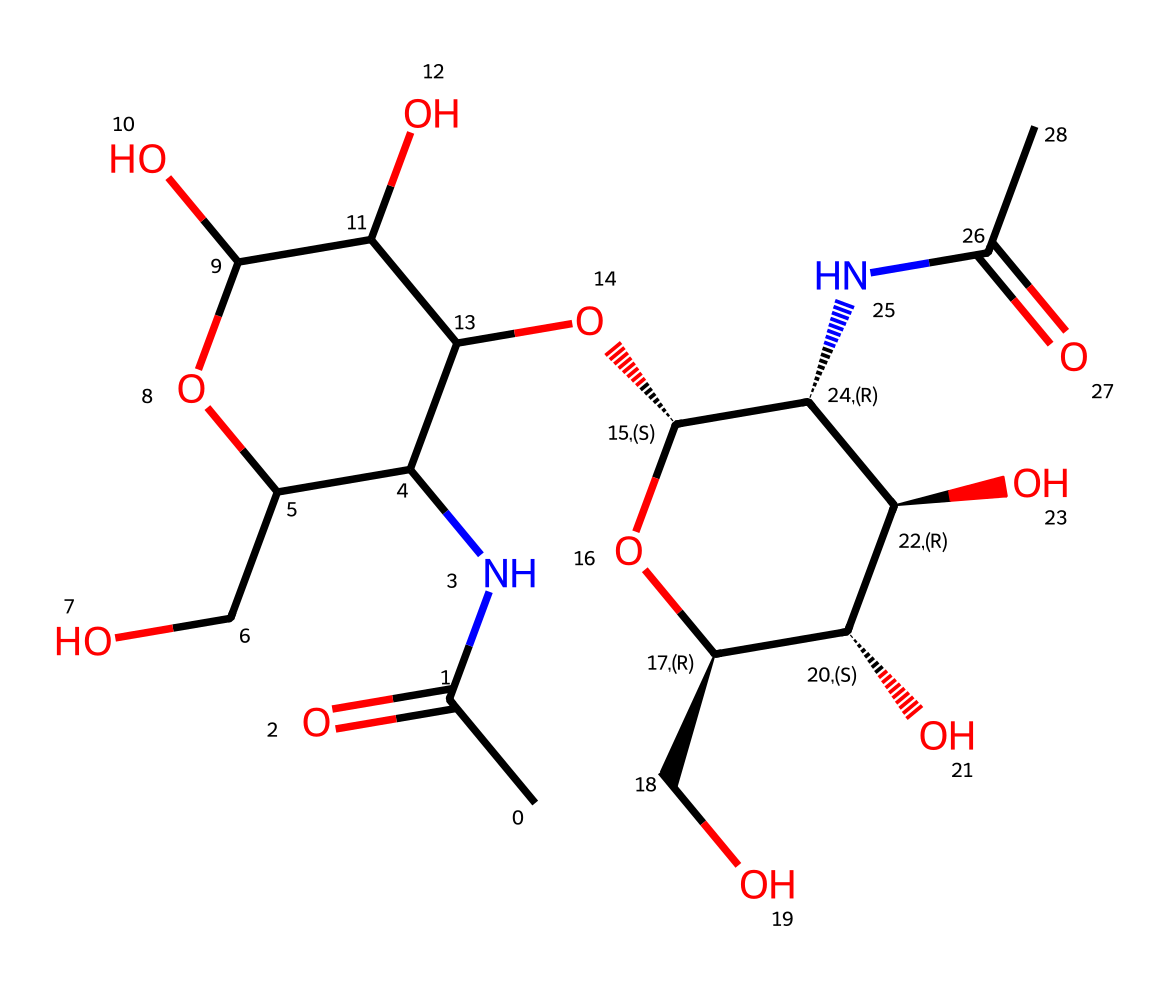how many carbon atoms are in this structure? By examining the structure derived from the SMILES notation, we can count the number of carbon atoms present. In this case, we tally the carbon atoms denoted by 'C' in the formula. There are a total of 14 carbon atoms.
Answer: 14 what type of bonds are present between carbon atoms? The structure indicates that there are single and double bonds. We can identify the presence of one double bond (seen in the 'CC(=O)' part) and multiple single bonds throughout the carbon backbone connecting them.
Answer: single and double which functional groups are present in this chemical? Analyzing the structural formula from the SMILES representation, we can identify carbonyl groups (C=O) and amine groups (N) as key functional groups. Additionally, hydroxyl groups (-OH) are also noted in the structure.
Answer: carbonyl and amine how many hydroxyl groups are in this structure? The count of hydroxyl groups can be determined by identifying the ‘O’ attached to hydrogen atoms (-OH). In this structure, there are four hydroxyl groups present, as indicated by the locations in the formula where Oxygen is bonded to Carbon alongside Hydrogen.
Answer: four is this compound likely to be polar or non-polar? Considering the presence of multiple polar functional groups such as hydroxyl and amine groups, the compound displays significant polarity. The electronegative oxygen and nitrogen atoms contribute to this trait, making it soluble in water.
Answer: polar what might be the role of this lubricant for dancers? The specific structure suggests that this lubricant could provide joint lubrication due to its ability to form a gel-like consistency, which can reduce friction and provide cushioning within joints during movement, especially while dancing.
Answer: joint lubrication 